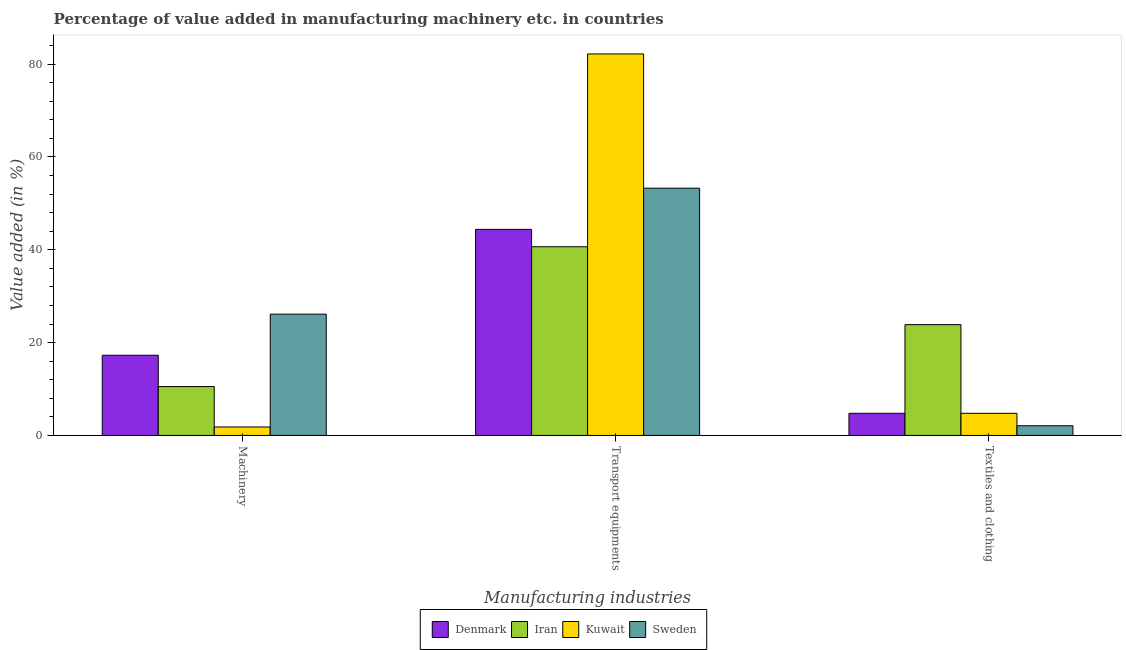How many groups of bars are there?
Your response must be concise. 3. Are the number of bars on each tick of the X-axis equal?
Make the answer very short. Yes. How many bars are there on the 3rd tick from the right?
Your answer should be compact. 4. What is the label of the 2nd group of bars from the left?
Make the answer very short. Transport equipments. What is the value added in manufacturing transport equipments in Denmark?
Give a very brief answer. 44.39. Across all countries, what is the maximum value added in manufacturing machinery?
Make the answer very short. 26.13. Across all countries, what is the minimum value added in manufacturing textile and clothing?
Keep it short and to the point. 2.09. In which country was the value added in manufacturing machinery minimum?
Your response must be concise. Kuwait. What is the total value added in manufacturing textile and clothing in the graph?
Your response must be concise. 35.5. What is the difference between the value added in manufacturing transport equipments in Sweden and that in Denmark?
Your answer should be very brief. 8.87. What is the difference between the value added in manufacturing textile and clothing in Iran and the value added in manufacturing transport equipments in Sweden?
Offer a terse response. -29.39. What is the average value added in manufacturing textile and clothing per country?
Keep it short and to the point. 8.87. What is the difference between the value added in manufacturing textile and clothing and value added in manufacturing transport equipments in Sweden?
Offer a very short reply. -51.17. In how many countries, is the value added in manufacturing transport equipments greater than 24 %?
Keep it short and to the point. 4. What is the ratio of the value added in manufacturing transport equipments in Kuwait to that in Denmark?
Provide a short and direct response. 1.85. What is the difference between the highest and the second highest value added in manufacturing transport equipments?
Ensure brevity in your answer.  28.92. What is the difference between the highest and the lowest value added in manufacturing transport equipments?
Give a very brief answer. 41.53. What does the 4th bar from the right in Textiles and clothing represents?
Make the answer very short. Denmark. How many bars are there?
Keep it short and to the point. 12. Are all the bars in the graph horizontal?
Offer a very short reply. No. Does the graph contain grids?
Offer a terse response. No. Where does the legend appear in the graph?
Your answer should be very brief. Bottom center. What is the title of the graph?
Provide a succinct answer. Percentage of value added in manufacturing machinery etc. in countries. Does "World" appear as one of the legend labels in the graph?
Ensure brevity in your answer.  No. What is the label or title of the X-axis?
Your response must be concise. Manufacturing industries. What is the label or title of the Y-axis?
Your response must be concise. Value added (in %). What is the Value added (in %) of Denmark in Machinery?
Keep it short and to the point. 17.28. What is the Value added (in %) in Iran in Machinery?
Make the answer very short. 10.53. What is the Value added (in %) in Kuwait in Machinery?
Make the answer very short. 1.82. What is the Value added (in %) in Sweden in Machinery?
Your response must be concise. 26.13. What is the Value added (in %) in Denmark in Transport equipments?
Provide a succinct answer. 44.39. What is the Value added (in %) in Iran in Transport equipments?
Offer a very short reply. 40.65. What is the Value added (in %) of Kuwait in Transport equipments?
Your answer should be very brief. 82.18. What is the Value added (in %) in Sweden in Transport equipments?
Your answer should be very brief. 53.26. What is the Value added (in %) in Denmark in Textiles and clothing?
Your answer should be very brief. 4.77. What is the Value added (in %) of Iran in Textiles and clothing?
Offer a very short reply. 23.87. What is the Value added (in %) in Kuwait in Textiles and clothing?
Your answer should be very brief. 4.77. What is the Value added (in %) of Sweden in Textiles and clothing?
Provide a short and direct response. 2.09. Across all Manufacturing industries, what is the maximum Value added (in %) of Denmark?
Make the answer very short. 44.39. Across all Manufacturing industries, what is the maximum Value added (in %) of Iran?
Keep it short and to the point. 40.65. Across all Manufacturing industries, what is the maximum Value added (in %) of Kuwait?
Keep it short and to the point. 82.18. Across all Manufacturing industries, what is the maximum Value added (in %) in Sweden?
Ensure brevity in your answer.  53.26. Across all Manufacturing industries, what is the minimum Value added (in %) of Denmark?
Give a very brief answer. 4.77. Across all Manufacturing industries, what is the minimum Value added (in %) of Iran?
Provide a succinct answer. 10.53. Across all Manufacturing industries, what is the minimum Value added (in %) of Kuwait?
Keep it short and to the point. 1.82. Across all Manufacturing industries, what is the minimum Value added (in %) of Sweden?
Keep it short and to the point. 2.09. What is the total Value added (in %) in Denmark in the graph?
Your answer should be compact. 66.43. What is the total Value added (in %) in Iran in the graph?
Offer a terse response. 75.05. What is the total Value added (in %) of Kuwait in the graph?
Give a very brief answer. 88.77. What is the total Value added (in %) of Sweden in the graph?
Ensure brevity in your answer.  81.48. What is the difference between the Value added (in %) of Denmark in Machinery and that in Transport equipments?
Provide a succinct answer. -27.12. What is the difference between the Value added (in %) of Iran in Machinery and that in Transport equipments?
Your answer should be compact. -30.12. What is the difference between the Value added (in %) of Kuwait in Machinery and that in Transport equipments?
Your response must be concise. -80.36. What is the difference between the Value added (in %) in Sweden in Machinery and that in Transport equipments?
Offer a terse response. -27.14. What is the difference between the Value added (in %) in Denmark in Machinery and that in Textiles and clothing?
Your response must be concise. 12.51. What is the difference between the Value added (in %) of Iran in Machinery and that in Textiles and clothing?
Ensure brevity in your answer.  -13.34. What is the difference between the Value added (in %) of Kuwait in Machinery and that in Textiles and clothing?
Ensure brevity in your answer.  -2.95. What is the difference between the Value added (in %) of Sweden in Machinery and that in Textiles and clothing?
Provide a succinct answer. 24.04. What is the difference between the Value added (in %) of Denmark in Transport equipments and that in Textiles and clothing?
Make the answer very short. 39.62. What is the difference between the Value added (in %) in Iran in Transport equipments and that in Textiles and clothing?
Provide a short and direct response. 16.78. What is the difference between the Value added (in %) in Kuwait in Transport equipments and that in Textiles and clothing?
Your answer should be very brief. 77.41. What is the difference between the Value added (in %) of Sweden in Transport equipments and that in Textiles and clothing?
Provide a short and direct response. 51.17. What is the difference between the Value added (in %) in Denmark in Machinery and the Value added (in %) in Iran in Transport equipments?
Offer a very short reply. -23.37. What is the difference between the Value added (in %) in Denmark in Machinery and the Value added (in %) in Kuwait in Transport equipments?
Keep it short and to the point. -64.9. What is the difference between the Value added (in %) in Denmark in Machinery and the Value added (in %) in Sweden in Transport equipments?
Offer a very short reply. -35.99. What is the difference between the Value added (in %) of Iran in Machinery and the Value added (in %) of Kuwait in Transport equipments?
Make the answer very short. -71.65. What is the difference between the Value added (in %) in Iran in Machinery and the Value added (in %) in Sweden in Transport equipments?
Make the answer very short. -42.74. What is the difference between the Value added (in %) of Kuwait in Machinery and the Value added (in %) of Sweden in Transport equipments?
Your answer should be compact. -51.44. What is the difference between the Value added (in %) of Denmark in Machinery and the Value added (in %) of Iran in Textiles and clothing?
Give a very brief answer. -6.59. What is the difference between the Value added (in %) of Denmark in Machinery and the Value added (in %) of Kuwait in Textiles and clothing?
Your response must be concise. 12.51. What is the difference between the Value added (in %) in Denmark in Machinery and the Value added (in %) in Sweden in Textiles and clothing?
Offer a very short reply. 15.18. What is the difference between the Value added (in %) of Iran in Machinery and the Value added (in %) of Kuwait in Textiles and clothing?
Your response must be concise. 5.76. What is the difference between the Value added (in %) in Iran in Machinery and the Value added (in %) in Sweden in Textiles and clothing?
Your answer should be very brief. 8.44. What is the difference between the Value added (in %) in Kuwait in Machinery and the Value added (in %) in Sweden in Textiles and clothing?
Provide a succinct answer. -0.27. What is the difference between the Value added (in %) in Denmark in Transport equipments and the Value added (in %) in Iran in Textiles and clothing?
Offer a terse response. 20.52. What is the difference between the Value added (in %) in Denmark in Transport equipments and the Value added (in %) in Kuwait in Textiles and clothing?
Ensure brevity in your answer.  39.62. What is the difference between the Value added (in %) in Denmark in Transport equipments and the Value added (in %) in Sweden in Textiles and clothing?
Give a very brief answer. 42.3. What is the difference between the Value added (in %) of Iran in Transport equipments and the Value added (in %) of Kuwait in Textiles and clothing?
Your response must be concise. 35.88. What is the difference between the Value added (in %) in Iran in Transport equipments and the Value added (in %) in Sweden in Textiles and clothing?
Make the answer very short. 38.56. What is the difference between the Value added (in %) in Kuwait in Transport equipments and the Value added (in %) in Sweden in Textiles and clothing?
Provide a succinct answer. 80.09. What is the average Value added (in %) of Denmark per Manufacturing industries?
Give a very brief answer. 22.14. What is the average Value added (in %) in Iran per Manufacturing industries?
Your response must be concise. 25.02. What is the average Value added (in %) of Kuwait per Manufacturing industries?
Make the answer very short. 29.59. What is the average Value added (in %) of Sweden per Manufacturing industries?
Your response must be concise. 27.16. What is the difference between the Value added (in %) in Denmark and Value added (in %) in Iran in Machinery?
Your answer should be compact. 6.75. What is the difference between the Value added (in %) in Denmark and Value added (in %) in Kuwait in Machinery?
Your answer should be compact. 15.46. What is the difference between the Value added (in %) of Denmark and Value added (in %) of Sweden in Machinery?
Keep it short and to the point. -8.85. What is the difference between the Value added (in %) in Iran and Value added (in %) in Kuwait in Machinery?
Offer a very short reply. 8.71. What is the difference between the Value added (in %) of Iran and Value added (in %) of Sweden in Machinery?
Ensure brevity in your answer.  -15.6. What is the difference between the Value added (in %) of Kuwait and Value added (in %) of Sweden in Machinery?
Ensure brevity in your answer.  -24.31. What is the difference between the Value added (in %) in Denmark and Value added (in %) in Iran in Transport equipments?
Make the answer very short. 3.74. What is the difference between the Value added (in %) of Denmark and Value added (in %) of Kuwait in Transport equipments?
Provide a short and direct response. -37.79. What is the difference between the Value added (in %) of Denmark and Value added (in %) of Sweden in Transport equipments?
Keep it short and to the point. -8.87. What is the difference between the Value added (in %) of Iran and Value added (in %) of Kuwait in Transport equipments?
Your response must be concise. -41.53. What is the difference between the Value added (in %) of Iran and Value added (in %) of Sweden in Transport equipments?
Your response must be concise. -12.61. What is the difference between the Value added (in %) of Kuwait and Value added (in %) of Sweden in Transport equipments?
Offer a very short reply. 28.92. What is the difference between the Value added (in %) in Denmark and Value added (in %) in Iran in Textiles and clothing?
Your answer should be very brief. -19.1. What is the difference between the Value added (in %) of Denmark and Value added (in %) of Kuwait in Textiles and clothing?
Provide a succinct answer. 0. What is the difference between the Value added (in %) of Denmark and Value added (in %) of Sweden in Textiles and clothing?
Provide a short and direct response. 2.68. What is the difference between the Value added (in %) in Iran and Value added (in %) in Kuwait in Textiles and clothing?
Your response must be concise. 19.1. What is the difference between the Value added (in %) of Iran and Value added (in %) of Sweden in Textiles and clothing?
Provide a short and direct response. 21.78. What is the difference between the Value added (in %) of Kuwait and Value added (in %) of Sweden in Textiles and clothing?
Your answer should be very brief. 2.68. What is the ratio of the Value added (in %) in Denmark in Machinery to that in Transport equipments?
Offer a terse response. 0.39. What is the ratio of the Value added (in %) in Iran in Machinery to that in Transport equipments?
Keep it short and to the point. 0.26. What is the ratio of the Value added (in %) of Kuwait in Machinery to that in Transport equipments?
Your answer should be very brief. 0.02. What is the ratio of the Value added (in %) in Sweden in Machinery to that in Transport equipments?
Offer a very short reply. 0.49. What is the ratio of the Value added (in %) in Denmark in Machinery to that in Textiles and clothing?
Give a very brief answer. 3.62. What is the ratio of the Value added (in %) in Iran in Machinery to that in Textiles and clothing?
Provide a succinct answer. 0.44. What is the ratio of the Value added (in %) of Kuwait in Machinery to that in Textiles and clothing?
Your answer should be compact. 0.38. What is the ratio of the Value added (in %) in Sweden in Machinery to that in Textiles and clothing?
Provide a short and direct response. 12.5. What is the ratio of the Value added (in %) of Denmark in Transport equipments to that in Textiles and clothing?
Your response must be concise. 9.31. What is the ratio of the Value added (in %) of Iran in Transport equipments to that in Textiles and clothing?
Your answer should be very brief. 1.7. What is the ratio of the Value added (in %) of Kuwait in Transport equipments to that in Textiles and clothing?
Your response must be concise. 17.24. What is the ratio of the Value added (in %) of Sweden in Transport equipments to that in Textiles and clothing?
Offer a terse response. 25.48. What is the difference between the highest and the second highest Value added (in %) of Denmark?
Your response must be concise. 27.12. What is the difference between the highest and the second highest Value added (in %) in Iran?
Give a very brief answer. 16.78. What is the difference between the highest and the second highest Value added (in %) of Kuwait?
Your response must be concise. 77.41. What is the difference between the highest and the second highest Value added (in %) of Sweden?
Keep it short and to the point. 27.14. What is the difference between the highest and the lowest Value added (in %) in Denmark?
Offer a very short reply. 39.62. What is the difference between the highest and the lowest Value added (in %) in Iran?
Offer a terse response. 30.12. What is the difference between the highest and the lowest Value added (in %) in Kuwait?
Provide a succinct answer. 80.36. What is the difference between the highest and the lowest Value added (in %) in Sweden?
Keep it short and to the point. 51.17. 